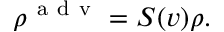Convert formula to latex. <formula><loc_0><loc_0><loc_500><loc_500>\rho ^ { a d v } = S ( v ) \rho .</formula> 